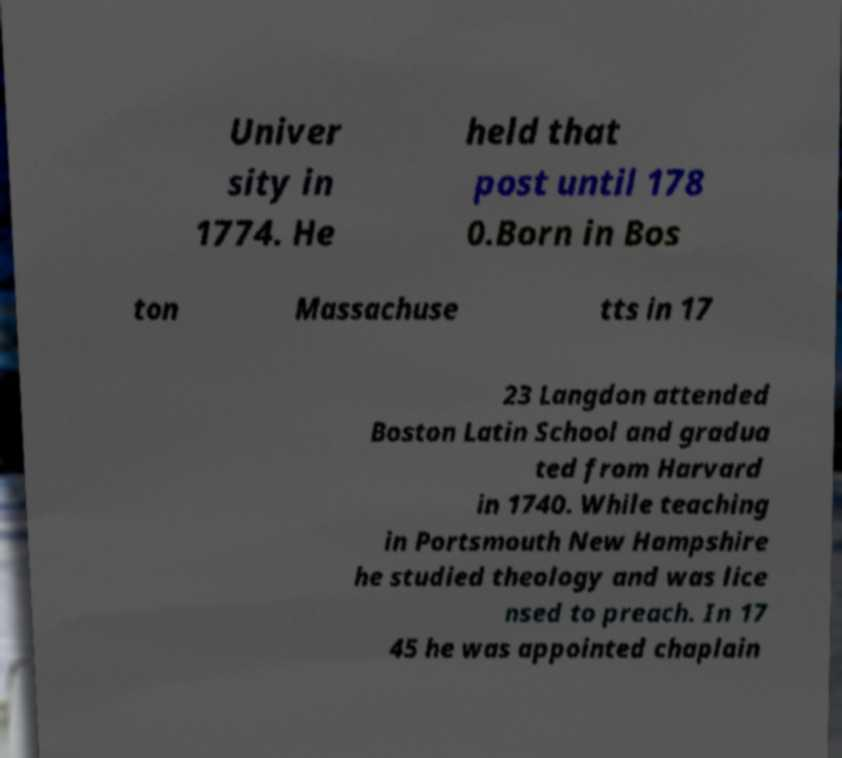Can you read and provide the text displayed in the image?This photo seems to have some interesting text. Can you extract and type it out for me? Univer sity in 1774. He held that post until 178 0.Born in Bos ton Massachuse tts in 17 23 Langdon attended Boston Latin School and gradua ted from Harvard in 1740. While teaching in Portsmouth New Hampshire he studied theology and was lice nsed to preach. In 17 45 he was appointed chaplain 